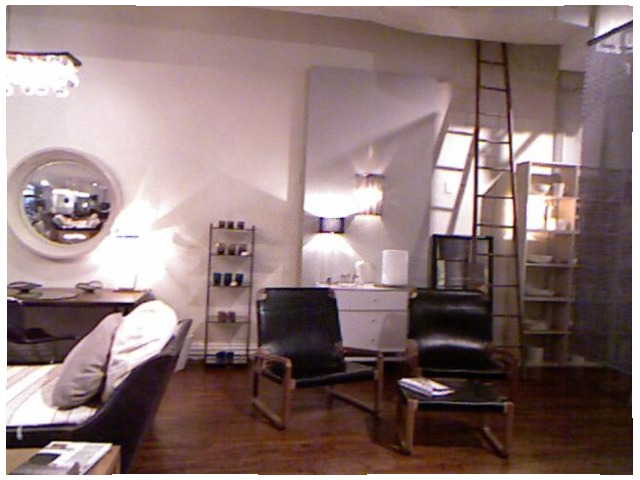<image>
Can you confirm if the book is on the stool? Yes. Looking at the image, I can see the book is positioned on top of the stool, with the stool providing support. Where is the mirror in relation to the wall? Is it on the wall? Yes. Looking at the image, I can see the mirror is positioned on top of the wall, with the wall providing support. Is there a chair on the wall? No. The chair is not positioned on the wall. They may be near each other, but the chair is not supported by or resting on top of the wall. Is the ladder behind the shadow? Yes. From this viewpoint, the ladder is positioned behind the shadow, with the shadow partially or fully occluding the ladder. Is there a ladder behind the chair? Yes. From this viewpoint, the ladder is positioned behind the chair, with the chair partially or fully occluding the ladder. 